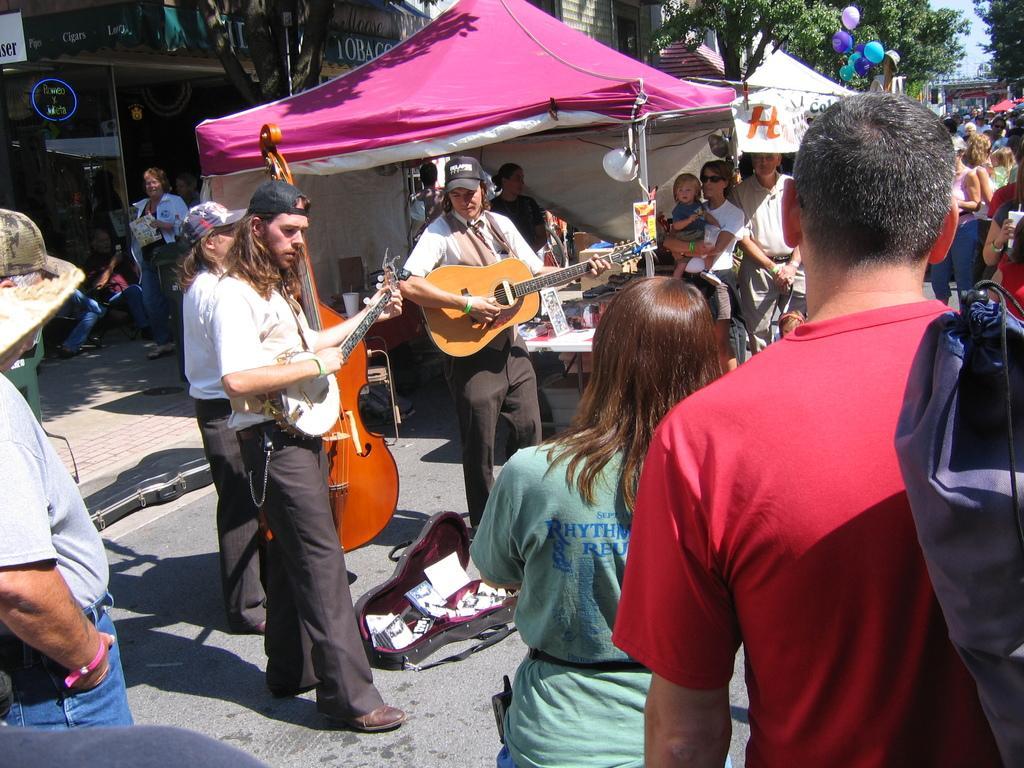How would you summarize this image in a sentence or two? It is an open area there is some event going on, the three people are playing guitar, behind there is a stall, there is a lot of crowd, in the background there are some other shops and a tree. 